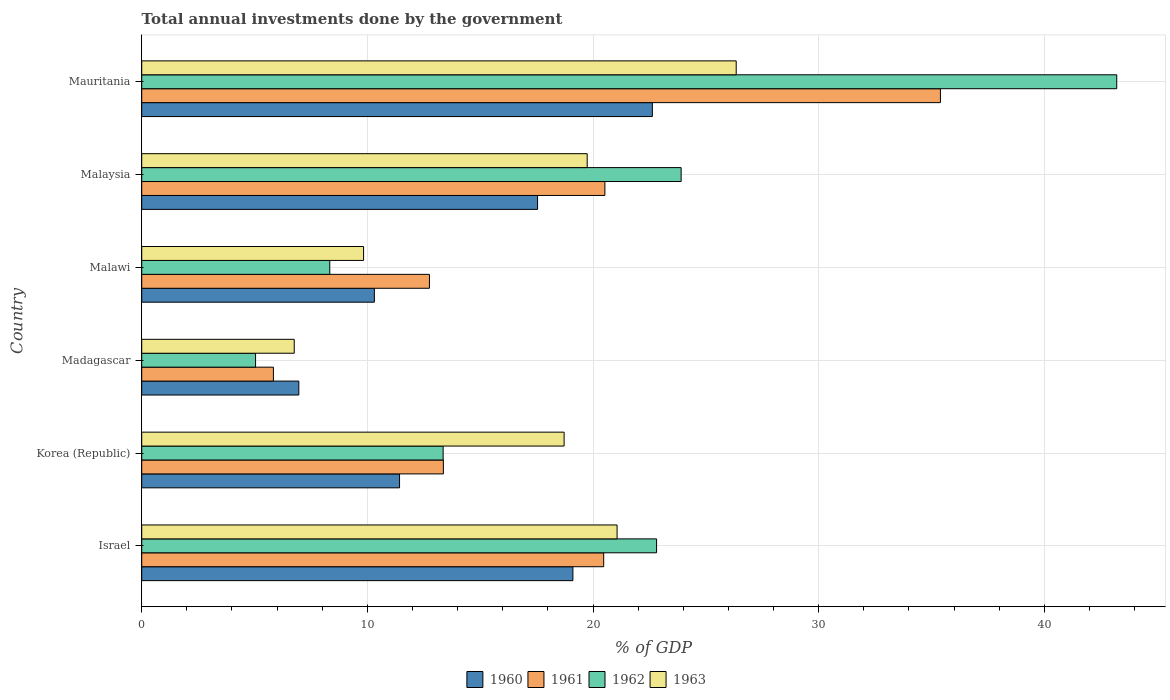How many different coloured bars are there?
Provide a succinct answer. 4. How many groups of bars are there?
Your answer should be very brief. 6. Are the number of bars per tick equal to the number of legend labels?
Offer a terse response. Yes. What is the label of the 1st group of bars from the top?
Provide a short and direct response. Mauritania. What is the total annual investments done by the government in 1960 in Malaysia?
Provide a short and direct response. 17.54. Across all countries, what is the maximum total annual investments done by the government in 1961?
Your response must be concise. 35.39. Across all countries, what is the minimum total annual investments done by the government in 1962?
Keep it short and to the point. 5.04. In which country was the total annual investments done by the government in 1960 maximum?
Offer a terse response. Mauritania. In which country was the total annual investments done by the government in 1960 minimum?
Your answer should be very brief. Madagascar. What is the total total annual investments done by the government in 1963 in the graph?
Keep it short and to the point. 102.46. What is the difference between the total annual investments done by the government in 1960 in Israel and that in Mauritania?
Ensure brevity in your answer.  -3.52. What is the difference between the total annual investments done by the government in 1960 in Malawi and the total annual investments done by the government in 1963 in Madagascar?
Give a very brief answer. 3.55. What is the average total annual investments done by the government in 1962 per country?
Offer a very short reply. 19.44. What is the difference between the total annual investments done by the government in 1961 and total annual investments done by the government in 1960 in Malawi?
Your response must be concise. 2.44. In how many countries, is the total annual investments done by the government in 1963 greater than 16 %?
Provide a succinct answer. 4. What is the ratio of the total annual investments done by the government in 1963 in Israel to that in Malawi?
Provide a succinct answer. 2.14. Is the total annual investments done by the government in 1963 in Madagascar less than that in Malaysia?
Give a very brief answer. Yes. What is the difference between the highest and the second highest total annual investments done by the government in 1963?
Give a very brief answer. 5.28. What is the difference between the highest and the lowest total annual investments done by the government in 1961?
Offer a terse response. 29.56. Is the sum of the total annual investments done by the government in 1962 in Israel and Korea (Republic) greater than the maximum total annual investments done by the government in 1961 across all countries?
Ensure brevity in your answer.  Yes. What does the 4th bar from the top in Malaysia represents?
Make the answer very short. 1960. Is it the case that in every country, the sum of the total annual investments done by the government in 1963 and total annual investments done by the government in 1962 is greater than the total annual investments done by the government in 1960?
Ensure brevity in your answer.  Yes. How many countries are there in the graph?
Provide a succinct answer. 6. Are the values on the major ticks of X-axis written in scientific E-notation?
Your answer should be very brief. No. Does the graph contain grids?
Your answer should be very brief. Yes. Where does the legend appear in the graph?
Your answer should be compact. Bottom center. How are the legend labels stacked?
Give a very brief answer. Horizontal. What is the title of the graph?
Your response must be concise. Total annual investments done by the government. Does "1965" appear as one of the legend labels in the graph?
Your response must be concise. No. What is the label or title of the X-axis?
Ensure brevity in your answer.  % of GDP. What is the % of GDP of 1960 in Israel?
Your answer should be very brief. 19.11. What is the % of GDP in 1961 in Israel?
Offer a terse response. 20.47. What is the % of GDP of 1962 in Israel?
Ensure brevity in your answer.  22.82. What is the % of GDP in 1963 in Israel?
Your answer should be very brief. 21.06. What is the % of GDP of 1960 in Korea (Republic)?
Make the answer very short. 11.43. What is the % of GDP in 1961 in Korea (Republic)?
Provide a short and direct response. 13.37. What is the % of GDP of 1962 in Korea (Republic)?
Your response must be concise. 13.36. What is the % of GDP of 1963 in Korea (Republic)?
Keep it short and to the point. 18.72. What is the % of GDP of 1960 in Madagascar?
Give a very brief answer. 6.96. What is the % of GDP of 1961 in Madagascar?
Provide a succinct answer. 5.84. What is the % of GDP in 1962 in Madagascar?
Keep it short and to the point. 5.04. What is the % of GDP of 1963 in Madagascar?
Offer a terse response. 6.76. What is the % of GDP in 1960 in Malawi?
Your response must be concise. 10.31. What is the % of GDP in 1961 in Malawi?
Keep it short and to the point. 12.75. What is the % of GDP of 1962 in Malawi?
Keep it short and to the point. 8.33. What is the % of GDP in 1963 in Malawi?
Provide a short and direct response. 9.83. What is the % of GDP in 1960 in Malaysia?
Keep it short and to the point. 17.54. What is the % of GDP in 1961 in Malaysia?
Provide a succinct answer. 20.52. What is the % of GDP of 1962 in Malaysia?
Ensure brevity in your answer.  23.9. What is the % of GDP in 1963 in Malaysia?
Offer a very short reply. 19.74. What is the % of GDP of 1960 in Mauritania?
Your response must be concise. 22.63. What is the % of GDP in 1961 in Mauritania?
Offer a terse response. 35.39. What is the % of GDP of 1962 in Mauritania?
Provide a short and direct response. 43.21. What is the % of GDP in 1963 in Mauritania?
Keep it short and to the point. 26.34. Across all countries, what is the maximum % of GDP in 1960?
Make the answer very short. 22.63. Across all countries, what is the maximum % of GDP in 1961?
Make the answer very short. 35.39. Across all countries, what is the maximum % of GDP in 1962?
Your answer should be very brief. 43.21. Across all countries, what is the maximum % of GDP in 1963?
Make the answer very short. 26.34. Across all countries, what is the minimum % of GDP in 1960?
Provide a short and direct response. 6.96. Across all countries, what is the minimum % of GDP of 1961?
Your response must be concise. 5.84. Across all countries, what is the minimum % of GDP of 1962?
Provide a succinct answer. 5.04. Across all countries, what is the minimum % of GDP of 1963?
Give a very brief answer. 6.76. What is the total % of GDP in 1960 in the graph?
Give a very brief answer. 87.97. What is the total % of GDP of 1961 in the graph?
Provide a short and direct response. 108.34. What is the total % of GDP in 1962 in the graph?
Make the answer very short. 116.66. What is the total % of GDP of 1963 in the graph?
Offer a terse response. 102.46. What is the difference between the % of GDP in 1960 in Israel and that in Korea (Republic)?
Offer a terse response. 7.68. What is the difference between the % of GDP in 1961 in Israel and that in Korea (Republic)?
Your answer should be very brief. 7.1. What is the difference between the % of GDP of 1962 in Israel and that in Korea (Republic)?
Provide a short and direct response. 9.46. What is the difference between the % of GDP of 1963 in Israel and that in Korea (Republic)?
Keep it short and to the point. 2.35. What is the difference between the % of GDP of 1960 in Israel and that in Madagascar?
Your answer should be very brief. 12.15. What is the difference between the % of GDP in 1961 in Israel and that in Madagascar?
Your response must be concise. 14.64. What is the difference between the % of GDP of 1962 in Israel and that in Madagascar?
Offer a terse response. 17.77. What is the difference between the % of GDP in 1963 in Israel and that in Madagascar?
Offer a very short reply. 14.31. What is the difference between the % of GDP of 1960 in Israel and that in Malawi?
Provide a short and direct response. 8.8. What is the difference between the % of GDP in 1961 in Israel and that in Malawi?
Make the answer very short. 7.72. What is the difference between the % of GDP of 1962 in Israel and that in Malawi?
Provide a succinct answer. 14.48. What is the difference between the % of GDP in 1963 in Israel and that in Malawi?
Your response must be concise. 11.23. What is the difference between the % of GDP in 1960 in Israel and that in Malaysia?
Ensure brevity in your answer.  1.57. What is the difference between the % of GDP in 1961 in Israel and that in Malaysia?
Keep it short and to the point. -0.05. What is the difference between the % of GDP of 1962 in Israel and that in Malaysia?
Give a very brief answer. -1.09. What is the difference between the % of GDP in 1963 in Israel and that in Malaysia?
Keep it short and to the point. 1.32. What is the difference between the % of GDP of 1960 in Israel and that in Mauritania?
Give a very brief answer. -3.52. What is the difference between the % of GDP of 1961 in Israel and that in Mauritania?
Provide a succinct answer. -14.92. What is the difference between the % of GDP of 1962 in Israel and that in Mauritania?
Keep it short and to the point. -20.39. What is the difference between the % of GDP of 1963 in Israel and that in Mauritania?
Provide a short and direct response. -5.28. What is the difference between the % of GDP in 1960 in Korea (Republic) and that in Madagascar?
Give a very brief answer. 4.46. What is the difference between the % of GDP of 1961 in Korea (Republic) and that in Madagascar?
Give a very brief answer. 7.53. What is the difference between the % of GDP in 1962 in Korea (Republic) and that in Madagascar?
Your answer should be very brief. 8.31. What is the difference between the % of GDP of 1963 in Korea (Republic) and that in Madagascar?
Give a very brief answer. 11.96. What is the difference between the % of GDP in 1960 in Korea (Republic) and that in Malawi?
Provide a short and direct response. 1.12. What is the difference between the % of GDP of 1961 in Korea (Republic) and that in Malawi?
Your response must be concise. 0.62. What is the difference between the % of GDP of 1962 in Korea (Republic) and that in Malawi?
Your answer should be very brief. 5.02. What is the difference between the % of GDP in 1963 in Korea (Republic) and that in Malawi?
Your answer should be very brief. 8.89. What is the difference between the % of GDP of 1960 in Korea (Republic) and that in Malaysia?
Provide a short and direct response. -6.12. What is the difference between the % of GDP in 1961 in Korea (Republic) and that in Malaysia?
Offer a terse response. -7.16. What is the difference between the % of GDP in 1962 in Korea (Republic) and that in Malaysia?
Provide a short and direct response. -10.55. What is the difference between the % of GDP in 1963 in Korea (Republic) and that in Malaysia?
Keep it short and to the point. -1.02. What is the difference between the % of GDP in 1960 in Korea (Republic) and that in Mauritania?
Ensure brevity in your answer.  -11.2. What is the difference between the % of GDP in 1961 in Korea (Republic) and that in Mauritania?
Your response must be concise. -22.03. What is the difference between the % of GDP of 1962 in Korea (Republic) and that in Mauritania?
Make the answer very short. -29.85. What is the difference between the % of GDP of 1963 in Korea (Republic) and that in Mauritania?
Ensure brevity in your answer.  -7.63. What is the difference between the % of GDP of 1960 in Madagascar and that in Malawi?
Offer a very short reply. -3.35. What is the difference between the % of GDP of 1961 in Madagascar and that in Malawi?
Offer a very short reply. -6.92. What is the difference between the % of GDP of 1962 in Madagascar and that in Malawi?
Provide a succinct answer. -3.29. What is the difference between the % of GDP in 1963 in Madagascar and that in Malawi?
Ensure brevity in your answer.  -3.07. What is the difference between the % of GDP in 1960 in Madagascar and that in Malaysia?
Your answer should be compact. -10.58. What is the difference between the % of GDP of 1961 in Madagascar and that in Malaysia?
Provide a succinct answer. -14.69. What is the difference between the % of GDP of 1962 in Madagascar and that in Malaysia?
Provide a short and direct response. -18.86. What is the difference between the % of GDP of 1963 in Madagascar and that in Malaysia?
Provide a succinct answer. -12.98. What is the difference between the % of GDP in 1960 in Madagascar and that in Mauritania?
Your response must be concise. -15.67. What is the difference between the % of GDP of 1961 in Madagascar and that in Mauritania?
Offer a terse response. -29.56. What is the difference between the % of GDP of 1962 in Madagascar and that in Mauritania?
Your answer should be compact. -38.16. What is the difference between the % of GDP of 1963 in Madagascar and that in Mauritania?
Ensure brevity in your answer.  -19.59. What is the difference between the % of GDP of 1960 in Malawi and that in Malaysia?
Give a very brief answer. -7.23. What is the difference between the % of GDP in 1961 in Malawi and that in Malaysia?
Provide a succinct answer. -7.77. What is the difference between the % of GDP of 1962 in Malawi and that in Malaysia?
Give a very brief answer. -15.57. What is the difference between the % of GDP in 1963 in Malawi and that in Malaysia?
Offer a terse response. -9.91. What is the difference between the % of GDP in 1960 in Malawi and that in Mauritania?
Offer a very short reply. -12.32. What is the difference between the % of GDP in 1961 in Malawi and that in Mauritania?
Offer a terse response. -22.64. What is the difference between the % of GDP of 1962 in Malawi and that in Mauritania?
Provide a succinct answer. -34.87. What is the difference between the % of GDP of 1963 in Malawi and that in Mauritania?
Offer a terse response. -16.51. What is the difference between the % of GDP in 1960 in Malaysia and that in Mauritania?
Ensure brevity in your answer.  -5.09. What is the difference between the % of GDP in 1961 in Malaysia and that in Mauritania?
Ensure brevity in your answer.  -14.87. What is the difference between the % of GDP in 1962 in Malaysia and that in Mauritania?
Your response must be concise. -19.3. What is the difference between the % of GDP of 1963 in Malaysia and that in Mauritania?
Offer a very short reply. -6.6. What is the difference between the % of GDP of 1960 in Israel and the % of GDP of 1961 in Korea (Republic)?
Give a very brief answer. 5.74. What is the difference between the % of GDP in 1960 in Israel and the % of GDP in 1962 in Korea (Republic)?
Offer a very short reply. 5.75. What is the difference between the % of GDP in 1960 in Israel and the % of GDP in 1963 in Korea (Republic)?
Provide a short and direct response. 0.39. What is the difference between the % of GDP in 1961 in Israel and the % of GDP in 1962 in Korea (Republic)?
Your answer should be very brief. 7.11. What is the difference between the % of GDP in 1961 in Israel and the % of GDP in 1963 in Korea (Republic)?
Give a very brief answer. 1.75. What is the difference between the % of GDP of 1962 in Israel and the % of GDP of 1963 in Korea (Republic)?
Offer a terse response. 4.1. What is the difference between the % of GDP in 1960 in Israel and the % of GDP in 1961 in Madagascar?
Offer a terse response. 13.27. What is the difference between the % of GDP of 1960 in Israel and the % of GDP of 1962 in Madagascar?
Ensure brevity in your answer.  14.06. What is the difference between the % of GDP in 1960 in Israel and the % of GDP in 1963 in Madagascar?
Keep it short and to the point. 12.35. What is the difference between the % of GDP of 1961 in Israel and the % of GDP of 1962 in Madagascar?
Make the answer very short. 15.43. What is the difference between the % of GDP in 1961 in Israel and the % of GDP in 1963 in Madagascar?
Make the answer very short. 13.71. What is the difference between the % of GDP in 1962 in Israel and the % of GDP in 1963 in Madagascar?
Offer a very short reply. 16.06. What is the difference between the % of GDP of 1960 in Israel and the % of GDP of 1961 in Malawi?
Provide a succinct answer. 6.36. What is the difference between the % of GDP in 1960 in Israel and the % of GDP in 1962 in Malawi?
Provide a short and direct response. 10.77. What is the difference between the % of GDP in 1960 in Israel and the % of GDP in 1963 in Malawi?
Give a very brief answer. 9.28. What is the difference between the % of GDP in 1961 in Israel and the % of GDP in 1962 in Malawi?
Ensure brevity in your answer.  12.14. What is the difference between the % of GDP of 1961 in Israel and the % of GDP of 1963 in Malawi?
Your response must be concise. 10.64. What is the difference between the % of GDP in 1962 in Israel and the % of GDP in 1963 in Malawi?
Your response must be concise. 12.98. What is the difference between the % of GDP of 1960 in Israel and the % of GDP of 1961 in Malaysia?
Your response must be concise. -1.42. What is the difference between the % of GDP in 1960 in Israel and the % of GDP in 1962 in Malaysia?
Provide a succinct answer. -4.8. What is the difference between the % of GDP in 1960 in Israel and the % of GDP in 1963 in Malaysia?
Ensure brevity in your answer.  -0.63. What is the difference between the % of GDP of 1961 in Israel and the % of GDP of 1962 in Malaysia?
Keep it short and to the point. -3.43. What is the difference between the % of GDP in 1961 in Israel and the % of GDP in 1963 in Malaysia?
Ensure brevity in your answer.  0.73. What is the difference between the % of GDP of 1962 in Israel and the % of GDP of 1963 in Malaysia?
Provide a succinct answer. 3.07. What is the difference between the % of GDP in 1960 in Israel and the % of GDP in 1961 in Mauritania?
Offer a terse response. -16.29. What is the difference between the % of GDP of 1960 in Israel and the % of GDP of 1962 in Mauritania?
Keep it short and to the point. -24.1. What is the difference between the % of GDP in 1960 in Israel and the % of GDP in 1963 in Mauritania?
Your response must be concise. -7.24. What is the difference between the % of GDP of 1961 in Israel and the % of GDP of 1962 in Mauritania?
Make the answer very short. -22.74. What is the difference between the % of GDP of 1961 in Israel and the % of GDP of 1963 in Mauritania?
Your answer should be very brief. -5.87. What is the difference between the % of GDP of 1962 in Israel and the % of GDP of 1963 in Mauritania?
Provide a succinct answer. -3.53. What is the difference between the % of GDP in 1960 in Korea (Republic) and the % of GDP in 1961 in Madagascar?
Give a very brief answer. 5.59. What is the difference between the % of GDP in 1960 in Korea (Republic) and the % of GDP in 1962 in Madagascar?
Offer a very short reply. 6.38. What is the difference between the % of GDP in 1960 in Korea (Republic) and the % of GDP in 1963 in Madagascar?
Give a very brief answer. 4.67. What is the difference between the % of GDP in 1961 in Korea (Republic) and the % of GDP in 1962 in Madagascar?
Ensure brevity in your answer.  8.32. What is the difference between the % of GDP in 1961 in Korea (Republic) and the % of GDP in 1963 in Madagascar?
Offer a very short reply. 6.61. What is the difference between the % of GDP of 1962 in Korea (Republic) and the % of GDP of 1963 in Madagascar?
Ensure brevity in your answer.  6.6. What is the difference between the % of GDP in 1960 in Korea (Republic) and the % of GDP in 1961 in Malawi?
Offer a very short reply. -1.33. What is the difference between the % of GDP of 1960 in Korea (Republic) and the % of GDP of 1962 in Malawi?
Offer a terse response. 3.09. What is the difference between the % of GDP of 1960 in Korea (Republic) and the % of GDP of 1963 in Malawi?
Offer a very short reply. 1.59. What is the difference between the % of GDP in 1961 in Korea (Republic) and the % of GDP in 1962 in Malawi?
Your answer should be very brief. 5.03. What is the difference between the % of GDP of 1961 in Korea (Republic) and the % of GDP of 1963 in Malawi?
Provide a succinct answer. 3.54. What is the difference between the % of GDP of 1962 in Korea (Republic) and the % of GDP of 1963 in Malawi?
Make the answer very short. 3.53. What is the difference between the % of GDP in 1960 in Korea (Republic) and the % of GDP in 1961 in Malaysia?
Keep it short and to the point. -9.1. What is the difference between the % of GDP in 1960 in Korea (Republic) and the % of GDP in 1962 in Malaysia?
Your response must be concise. -12.48. What is the difference between the % of GDP of 1960 in Korea (Republic) and the % of GDP of 1963 in Malaysia?
Your answer should be compact. -8.32. What is the difference between the % of GDP of 1961 in Korea (Republic) and the % of GDP of 1962 in Malaysia?
Offer a terse response. -10.54. What is the difference between the % of GDP of 1961 in Korea (Republic) and the % of GDP of 1963 in Malaysia?
Ensure brevity in your answer.  -6.37. What is the difference between the % of GDP of 1962 in Korea (Republic) and the % of GDP of 1963 in Malaysia?
Offer a very short reply. -6.38. What is the difference between the % of GDP in 1960 in Korea (Republic) and the % of GDP in 1961 in Mauritania?
Your answer should be very brief. -23.97. What is the difference between the % of GDP of 1960 in Korea (Republic) and the % of GDP of 1962 in Mauritania?
Provide a succinct answer. -31.78. What is the difference between the % of GDP in 1960 in Korea (Republic) and the % of GDP in 1963 in Mauritania?
Provide a short and direct response. -14.92. What is the difference between the % of GDP in 1961 in Korea (Republic) and the % of GDP in 1962 in Mauritania?
Offer a terse response. -29.84. What is the difference between the % of GDP of 1961 in Korea (Republic) and the % of GDP of 1963 in Mauritania?
Your answer should be very brief. -12.98. What is the difference between the % of GDP in 1962 in Korea (Republic) and the % of GDP in 1963 in Mauritania?
Ensure brevity in your answer.  -12.99. What is the difference between the % of GDP of 1960 in Madagascar and the % of GDP of 1961 in Malawi?
Your answer should be very brief. -5.79. What is the difference between the % of GDP of 1960 in Madagascar and the % of GDP of 1962 in Malawi?
Your answer should be compact. -1.37. What is the difference between the % of GDP of 1960 in Madagascar and the % of GDP of 1963 in Malawi?
Provide a succinct answer. -2.87. What is the difference between the % of GDP of 1961 in Madagascar and the % of GDP of 1962 in Malawi?
Keep it short and to the point. -2.5. What is the difference between the % of GDP in 1961 in Madagascar and the % of GDP in 1963 in Malawi?
Your answer should be very brief. -4. What is the difference between the % of GDP of 1962 in Madagascar and the % of GDP of 1963 in Malawi?
Offer a terse response. -4.79. What is the difference between the % of GDP in 1960 in Madagascar and the % of GDP in 1961 in Malaysia?
Provide a succinct answer. -13.56. What is the difference between the % of GDP of 1960 in Madagascar and the % of GDP of 1962 in Malaysia?
Your answer should be very brief. -16.94. What is the difference between the % of GDP in 1960 in Madagascar and the % of GDP in 1963 in Malaysia?
Your answer should be very brief. -12.78. What is the difference between the % of GDP in 1961 in Madagascar and the % of GDP in 1962 in Malaysia?
Offer a very short reply. -18.07. What is the difference between the % of GDP in 1961 in Madagascar and the % of GDP in 1963 in Malaysia?
Offer a terse response. -13.9. What is the difference between the % of GDP of 1962 in Madagascar and the % of GDP of 1963 in Malaysia?
Provide a short and direct response. -14.7. What is the difference between the % of GDP in 1960 in Madagascar and the % of GDP in 1961 in Mauritania?
Offer a terse response. -28.43. What is the difference between the % of GDP in 1960 in Madagascar and the % of GDP in 1962 in Mauritania?
Make the answer very short. -36.25. What is the difference between the % of GDP of 1960 in Madagascar and the % of GDP of 1963 in Mauritania?
Your response must be concise. -19.38. What is the difference between the % of GDP of 1961 in Madagascar and the % of GDP of 1962 in Mauritania?
Offer a very short reply. -37.37. What is the difference between the % of GDP in 1961 in Madagascar and the % of GDP in 1963 in Mauritania?
Ensure brevity in your answer.  -20.51. What is the difference between the % of GDP of 1962 in Madagascar and the % of GDP of 1963 in Mauritania?
Your answer should be very brief. -21.3. What is the difference between the % of GDP of 1960 in Malawi and the % of GDP of 1961 in Malaysia?
Give a very brief answer. -10.22. What is the difference between the % of GDP of 1960 in Malawi and the % of GDP of 1962 in Malaysia?
Offer a very short reply. -13.59. What is the difference between the % of GDP in 1960 in Malawi and the % of GDP in 1963 in Malaysia?
Provide a succinct answer. -9.43. What is the difference between the % of GDP of 1961 in Malawi and the % of GDP of 1962 in Malaysia?
Your answer should be very brief. -11.15. What is the difference between the % of GDP in 1961 in Malawi and the % of GDP in 1963 in Malaysia?
Make the answer very short. -6.99. What is the difference between the % of GDP of 1962 in Malawi and the % of GDP of 1963 in Malaysia?
Make the answer very short. -11.41. What is the difference between the % of GDP in 1960 in Malawi and the % of GDP in 1961 in Mauritania?
Keep it short and to the point. -25.08. What is the difference between the % of GDP of 1960 in Malawi and the % of GDP of 1962 in Mauritania?
Make the answer very short. -32.9. What is the difference between the % of GDP in 1960 in Malawi and the % of GDP in 1963 in Mauritania?
Give a very brief answer. -16.03. What is the difference between the % of GDP of 1961 in Malawi and the % of GDP of 1962 in Mauritania?
Give a very brief answer. -30.46. What is the difference between the % of GDP of 1961 in Malawi and the % of GDP of 1963 in Mauritania?
Keep it short and to the point. -13.59. What is the difference between the % of GDP of 1962 in Malawi and the % of GDP of 1963 in Mauritania?
Keep it short and to the point. -18.01. What is the difference between the % of GDP in 1960 in Malaysia and the % of GDP in 1961 in Mauritania?
Keep it short and to the point. -17.85. What is the difference between the % of GDP of 1960 in Malaysia and the % of GDP of 1962 in Mauritania?
Make the answer very short. -25.67. What is the difference between the % of GDP of 1960 in Malaysia and the % of GDP of 1963 in Mauritania?
Provide a succinct answer. -8.8. What is the difference between the % of GDP of 1961 in Malaysia and the % of GDP of 1962 in Mauritania?
Make the answer very short. -22.68. What is the difference between the % of GDP in 1961 in Malaysia and the % of GDP in 1963 in Mauritania?
Provide a succinct answer. -5.82. What is the difference between the % of GDP of 1962 in Malaysia and the % of GDP of 1963 in Mauritania?
Your answer should be very brief. -2.44. What is the average % of GDP of 1960 per country?
Offer a terse response. 14.66. What is the average % of GDP of 1961 per country?
Ensure brevity in your answer.  18.06. What is the average % of GDP of 1962 per country?
Your answer should be very brief. 19.44. What is the average % of GDP of 1963 per country?
Provide a succinct answer. 17.08. What is the difference between the % of GDP of 1960 and % of GDP of 1961 in Israel?
Provide a succinct answer. -1.36. What is the difference between the % of GDP of 1960 and % of GDP of 1962 in Israel?
Your answer should be compact. -3.71. What is the difference between the % of GDP of 1960 and % of GDP of 1963 in Israel?
Your answer should be compact. -1.96. What is the difference between the % of GDP of 1961 and % of GDP of 1962 in Israel?
Keep it short and to the point. -2.34. What is the difference between the % of GDP in 1961 and % of GDP in 1963 in Israel?
Provide a short and direct response. -0.59. What is the difference between the % of GDP in 1962 and % of GDP in 1963 in Israel?
Give a very brief answer. 1.75. What is the difference between the % of GDP of 1960 and % of GDP of 1961 in Korea (Republic)?
Offer a very short reply. -1.94. What is the difference between the % of GDP of 1960 and % of GDP of 1962 in Korea (Republic)?
Your answer should be very brief. -1.93. What is the difference between the % of GDP in 1960 and % of GDP in 1963 in Korea (Republic)?
Provide a succinct answer. -7.29. What is the difference between the % of GDP in 1961 and % of GDP in 1962 in Korea (Republic)?
Give a very brief answer. 0.01. What is the difference between the % of GDP of 1961 and % of GDP of 1963 in Korea (Republic)?
Your answer should be very brief. -5.35. What is the difference between the % of GDP of 1962 and % of GDP of 1963 in Korea (Republic)?
Provide a short and direct response. -5.36. What is the difference between the % of GDP of 1960 and % of GDP of 1961 in Madagascar?
Offer a terse response. 1.13. What is the difference between the % of GDP of 1960 and % of GDP of 1962 in Madagascar?
Give a very brief answer. 1.92. What is the difference between the % of GDP in 1960 and % of GDP in 1963 in Madagascar?
Provide a short and direct response. 0.2. What is the difference between the % of GDP in 1961 and % of GDP in 1962 in Madagascar?
Offer a very short reply. 0.79. What is the difference between the % of GDP of 1961 and % of GDP of 1963 in Madagascar?
Provide a short and direct response. -0.92. What is the difference between the % of GDP in 1962 and % of GDP in 1963 in Madagascar?
Your answer should be compact. -1.71. What is the difference between the % of GDP of 1960 and % of GDP of 1961 in Malawi?
Provide a short and direct response. -2.44. What is the difference between the % of GDP in 1960 and % of GDP in 1962 in Malawi?
Ensure brevity in your answer.  1.98. What is the difference between the % of GDP in 1960 and % of GDP in 1963 in Malawi?
Offer a very short reply. 0.48. What is the difference between the % of GDP of 1961 and % of GDP of 1962 in Malawi?
Your response must be concise. 4.42. What is the difference between the % of GDP of 1961 and % of GDP of 1963 in Malawi?
Your response must be concise. 2.92. What is the difference between the % of GDP of 1962 and % of GDP of 1963 in Malawi?
Provide a short and direct response. -1.5. What is the difference between the % of GDP in 1960 and % of GDP in 1961 in Malaysia?
Provide a succinct answer. -2.98. What is the difference between the % of GDP in 1960 and % of GDP in 1962 in Malaysia?
Give a very brief answer. -6.36. What is the difference between the % of GDP of 1960 and % of GDP of 1963 in Malaysia?
Offer a terse response. -2.2. What is the difference between the % of GDP of 1961 and % of GDP of 1962 in Malaysia?
Your answer should be compact. -3.38. What is the difference between the % of GDP in 1961 and % of GDP in 1963 in Malaysia?
Your response must be concise. 0.78. What is the difference between the % of GDP in 1962 and % of GDP in 1963 in Malaysia?
Keep it short and to the point. 4.16. What is the difference between the % of GDP in 1960 and % of GDP in 1961 in Mauritania?
Your response must be concise. -12.77. What is the difference between the % of GDP of 1960 and % of GDP of 1962 in Mauritania?
Your response must be concise. -20.58. What is the difference between the % of GDP in 1960 and % of GDP in 1963 in Mauritania?
Your answer should be compact. -3.72. What is the difference between the % of GDP in 1961 and % of GDP in 1962 in Mauritania?
Your response must be concise. -7.81. What is the difference between the % of GDP of 1961 and % of GDP of 1963 in Mauritania?
Provide a succinct answer. 9.05. What is the difference between the % of GDP of 1962 and % of GDP of 1963 in Mauritania?
Provide a short and direct response. 16.86. What is the ratio of the % of GDP in 1960 in Israel to that in Korea (Republic)?
Your response must be concise. 1.67. What is the ratio of the % of GDP of 1961 in Israel to that in Korea (Republic)?
Provide a short and direct response. 1.53. What is the ratio of the % of GDP in 1962 in Israel to that in Korea (Republic)?
Give a very brief answer. 1.71. What is the ratio of the % of GDP in 1963 in Israel to that in Korea (Republic)?
Provide a succinct answer. 1.13. What is the ratio of the % of GDP in 1960 in Israel to that in Madagascar?
Ensure brevity in your answer.  2.74. What is the ratio of the % of GDP in 1961 in Israel to that in Madagascar?
Your answer should be compact. 3.51. What is the ratio of the % of GDP in 1962 in Israel to that in Madagascar?
Ensure brevity in your answer.  4.52. What is the ratio of the % of GDP of 1963 in Israel to that in Madagascar?
Your answer should be very brief. 3.12. What is the ratio of the % of GDP of 1960 in Israel to that in Malawi?
Ensure brevity in your answer.  1.85. What is the ratio of the % of GDP of 1961 in Israel to that in Malawi?
Your answer should be very brief. 1.61. What is the ratio of the % of GDP of 1962 in Israel to that in Malawi?
Offer a terse response. 2.74. What is the ratio of the % of GDP of 1963 in Israel to that in Malawi?
Your answer should be compact. 2.14. What is the ratio of the % of GDP of 1960 in Israel to that in Malaysia?
Your response must be concise. 1.09. What is the ratio of the % of GDP in 1961 in Israel to that in Malaysia?
Keep it short and to the point. 1. What is the ratio of the % of GDP in 1962 in Israel to that in Malaysia?
Ensure brevity in your answer.  0.95. What is the ratio of the % of GDP of 1963 in Israel to that in Malaysia?
Your answer should be very brief. 1.07. What is the ratio of the % of GDP of 1960 in Israel to that in Mauritania?
Provide a succinct answer. 0.84. What is the ratio of the % of GDP of 1961 in Israel to that in Mauritania?
Provide a succinct answer. 0.58. What is the ratio of the % of GDP of 1962 in Israel to that in Mauritania?
Your answer should be very brief. 0.53. What is the ratio of the % of GDP in 1963 in Israel to that in Mauritania?
Make the answer very short. 0.8. What is the ratio of the % of GDP of 1960 in Korea (Republic) to that in Madagascar?
Keep it short and to the point. 1.64. What is the ratio of the % of GDP of 1961 in Korea (Republic) to that in Madagascar?
Provide a succinct answer. 2.29. What is the ratio of the % of GDP of 1962 in Korea (Republic) to that in Madagascar?
Your answer should be very brief. 2.65. What is the ratio of the % of GDP of 1963 in Korea (Republic) to that in Madagascar?
Offer a terse response. 2.77. What is the ratio of the % of GDP of 1960 in Korea (Republic) to that in Malawi?
Keep it short and to the point. 1.11. What is the ratio of the % of GDP in 1961 in Korea (Republic) to that in Malawi?
Your answer should be very brief. 1.05. What is the ratio of the % of GDP of 1962 in Korea (Republic) to that in Malawi?
Your response must be concise. 1.6. What is the ratio of the % of GDP in 1963 in Korea (Republic) to that in Malawi?
Provide a short and direct response. 1.9. What is the ratio of the % of GDP in 1960 in Korea (Republic) to that in Malaysia?
Provide a short and direct response. 0.65. What is the ratio of the % of GDP of 1961 in Korea (Republic) to that in Malaysia?
Make the answer very short. 0.65. What is the ratio of the % of GDP of 1962 in Korea (Republic) to that in Malaysia?
Provide a succinct answer. 0.56. What is the ratio of the % of GDP of 1963 in Korea (Republic) to that in Malaysia?
Make the answer very short. 0.95. What is the ratio of the % of GDP in 1960 in Korea (Republic) to that in Mauritania?
Provide a short and direct response. 0.5. What is the ratio of the % of GDP in 1961 in Korea (Republic) to that in Mauritania?
Give a very brief answer. 0.38. What is the ratio of the % of GDP of 1962 in Korea (Republic) to that in Mauritania?
Ensure brevity in your answer.  0.31. What is the ratio of the % of GDP in 1963 in Korea (Republic) to that in Mauritania?
Offer a terse response. 0.71. What is the ratio of the % of GDP in 1960 in Madagascar to that in Malawi?
Provide a succinct answer. 0.68. What is the ratio of the % of GDP in 1961 in Madagascar to that in Malawi?
Your response must be concise. 0.46. What is the ratio of the % of GDP in 1962 in Madagascar to that in Malawi?
Make the answer very short. 0.61. What is the ratio of the % of GDP of 1963 in Madagascar to that in Malawi?
Give a very brief answer. 0.69. What is the ratio of the % of GDP of 1960 in Madagascar to that in Malaysia?
Your response must be concise. 0.4. What is the ratio of the % of GDP in 1961 in Madagascar to that in Malaysia?
Provide a succinct answer. 0.28. What is the ratio of the % of GDP of 1962 in Madagascar to that in Malaysia?
Offer a very short reply. 0.21. What is the ratio of the % of GDP of 1963 in Madagascar to that in Malaysia?
Make the answer very short. 0.34. What is the ratio of the % of GDP of 1960 in Madagascar to that in Mauritania?
Offer a very short reply. 0.31. What is the ratio of the % of GDP of 1961 in Madagascar to that in Mauritania?
Your response must be concise. 0.16. What is the ratio of the % of GDP of 1962 in Madagascar to that in Mauritania?
Provide a short and direct response. 0.12. What is the ratio of the % of GDP of 1963 in Madagascar to that in Mauritania?
Your response must be concise. 0.26. What is the ratio of the % of GDP of 1960 in Malawi to that in Malaysia?
Your answer should be compact. 0.59. What is the ratio of the % of GDP in 1961 in Malawi to that in Malaysia?
Give a very brief answer. 0.62. What is the ratio of the % of GDP in 1962 in Malawi to that in Malaysia?
Provide a succinct answer. 0.35. What is the ratio of the % of GDP in 1963 in Malawi to that in Malaysia?
Offer a very short reply. 0.5. What is the ratio of the % of GDP of 1960 in Malawi to that in Mauritania?
Offer a terse response. 0.46. What is the ratio of the % of GDP in 1961 in Malawi to that in Mauritania?
Give a very brief answer. 0.36. What is the ratio of the % of GDP of 1962 in Malawi to that in Mauritania?
Your response must be concise. 0.19. What is the ratio of the % of GDP in 1963 in Malawi to that in Mauritania?
Your response must be concise. 0.37. What is the ratio of the % of GDP of 1960 in Malaysia to that in Mauritania?
Give a very brief answer. 0.78. What is the ratio of the % of GDP of 1961 in Malaysia to that in Mauritania?
Provide a succinct answer. 0.58. What is the ratio of the % of GDP of 1962 in Malaysia to that in Mauritania?
Your answer should be compact. 0.55. What is the ratio of the % of GDP of 1963 in Malaysia to that in Mauritania?
Keep it short and to the point. 0.75. What is the difference between the highest and the second highest % of GDP of 1960?
Make the answer very short. 3.52. What is the difference between the highest and the second highest % of GDP in 1961?
Offer a terse response. 14.87. What is the difference between the highest and the second highest % of GDP of 1962?
Make the answer very short. 19.3. What is the difference between the highest and the second highest % of GDP in 1963?
Offer a terse response. 5.28. What is the difference between the highest and the lowest % of GDP in 1960?
Provide a short and direct response. 15.67. What is the difference between the highest and the lowest % of GDP of 1961?
Provide a short and direct response. 29.56. What is the difference between the highest and the lowest % of GDP in 1962?
Your response must be concise. 38.16. What is the difference between the highest and the lowest % of GDP in 1963?
Give a very brief answer. 19.59. 